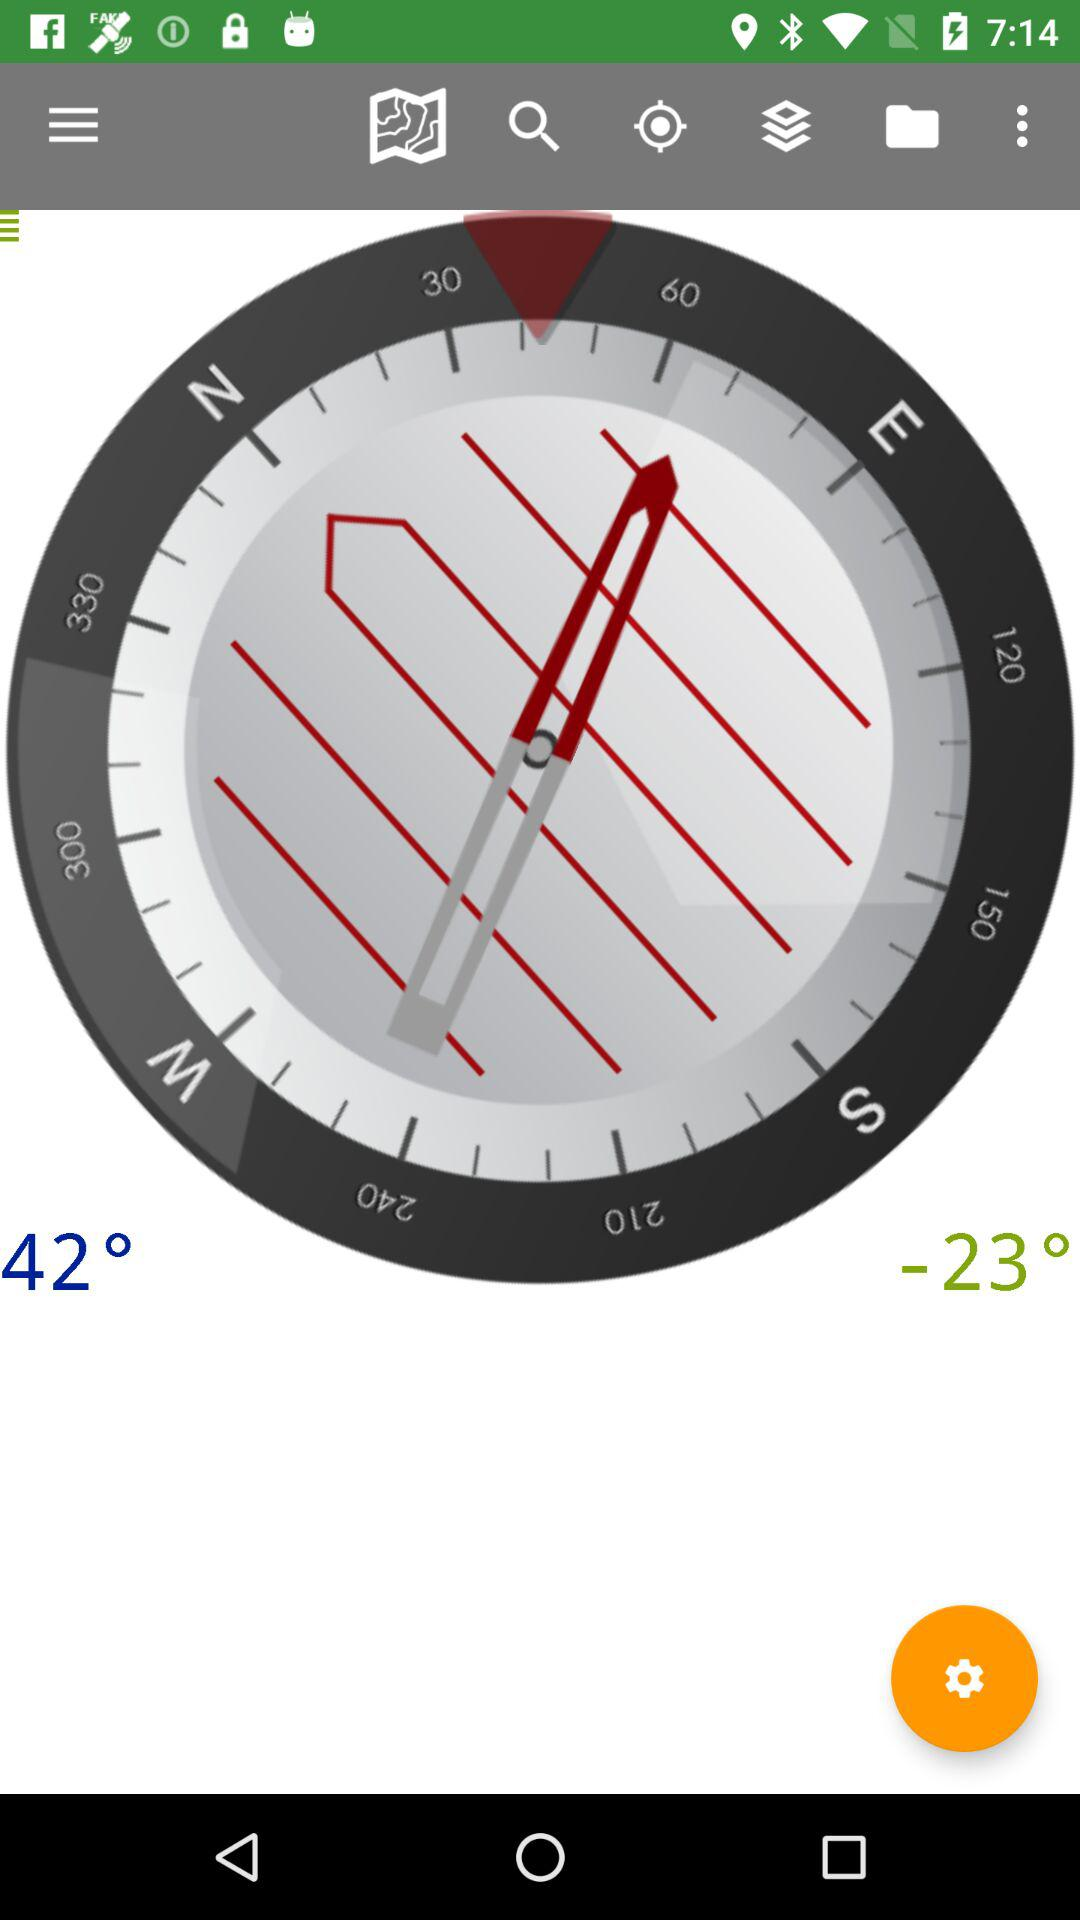How many degrees is the difference between the two compass readings?
Answer the question using a single word or phrase. 65 